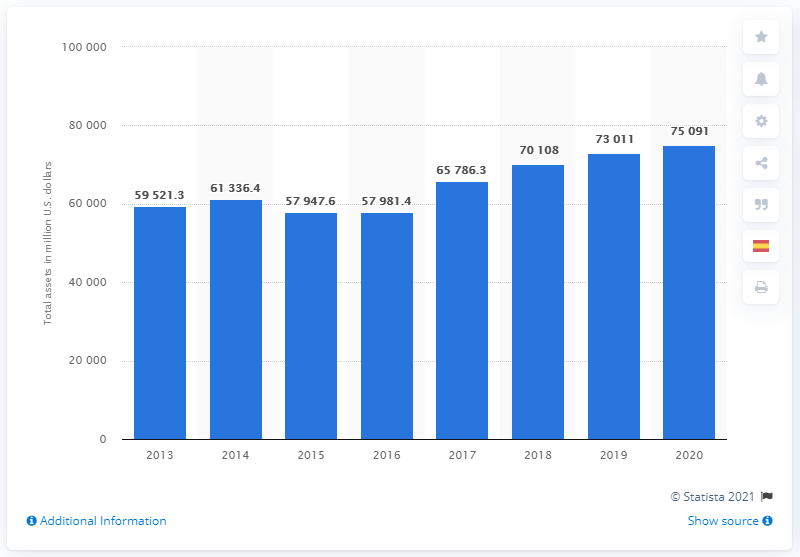Mention a couple of crucial points in this snapshot. In 2014, the total assets of John Deere were approximately 61,336.4. 